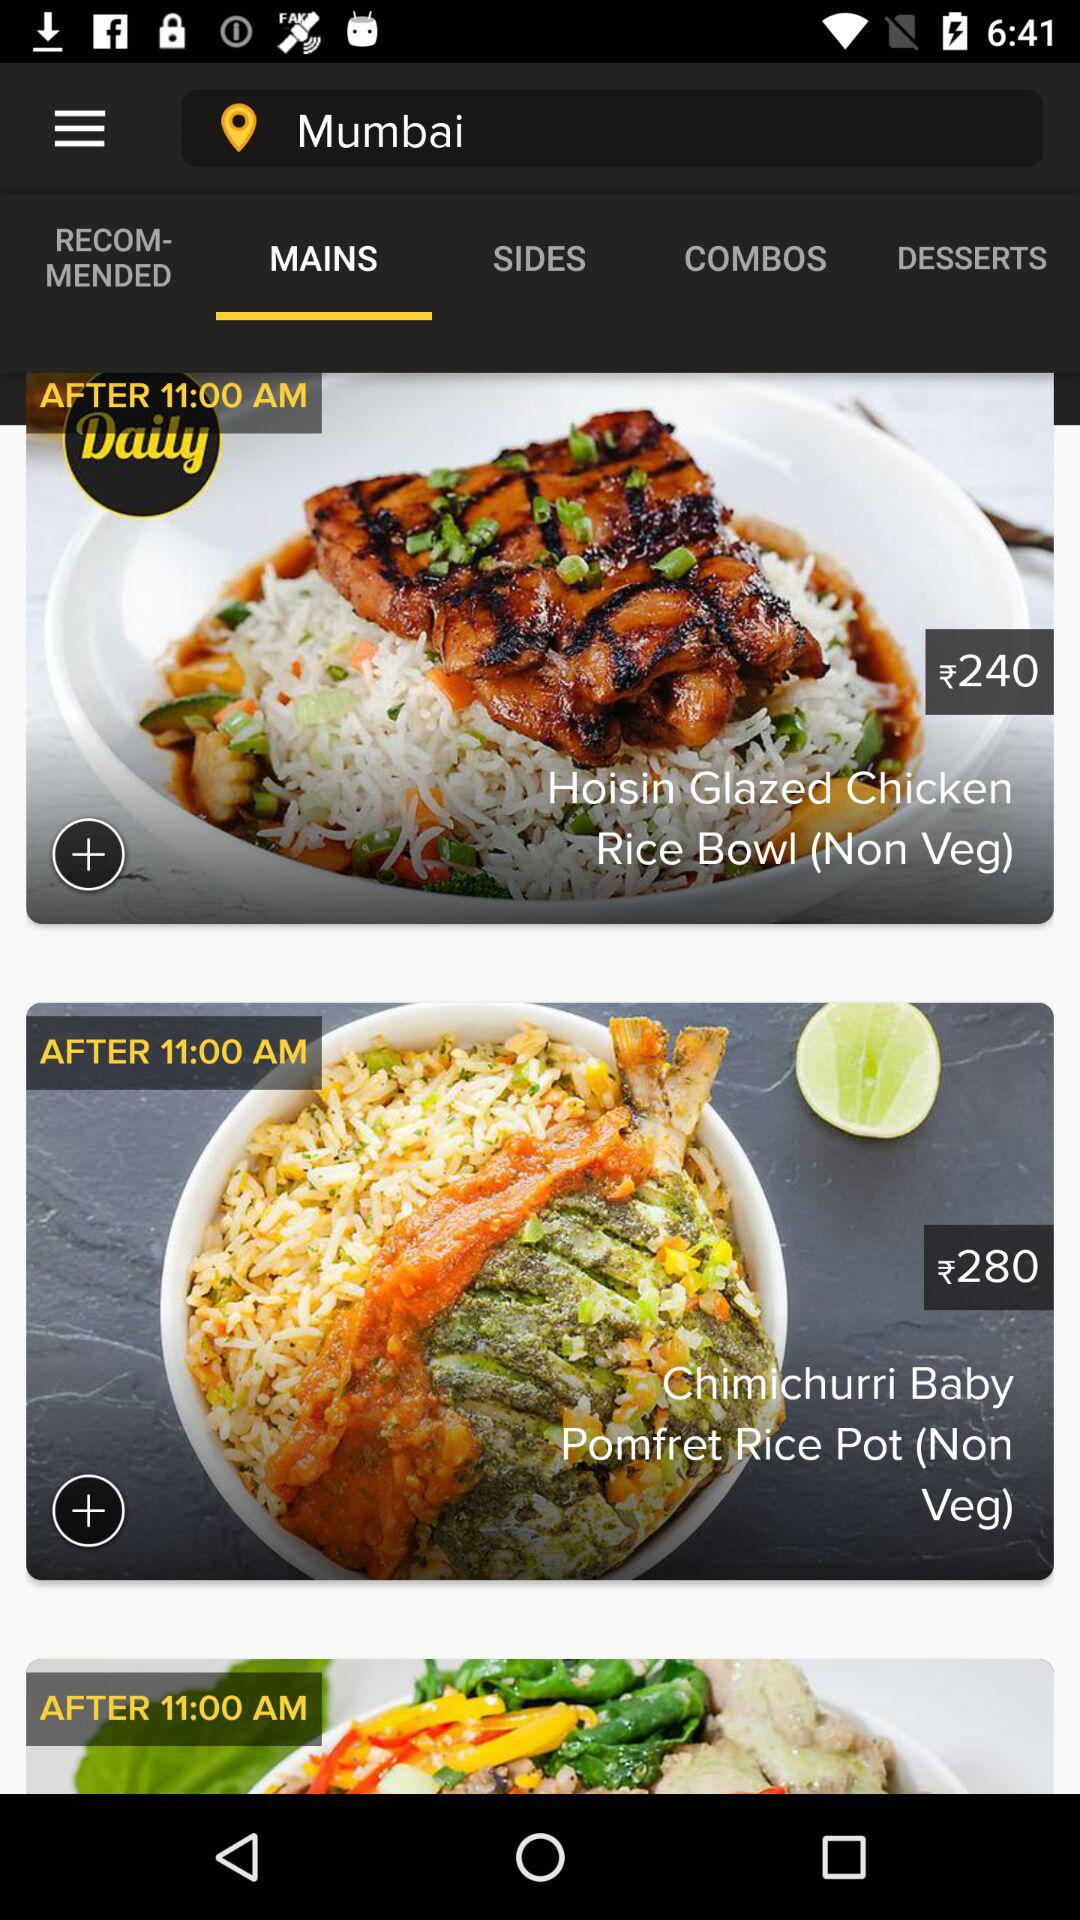What is the timing shown?
When the provided information is insufficient, respond with <no answer>. <no answer> 